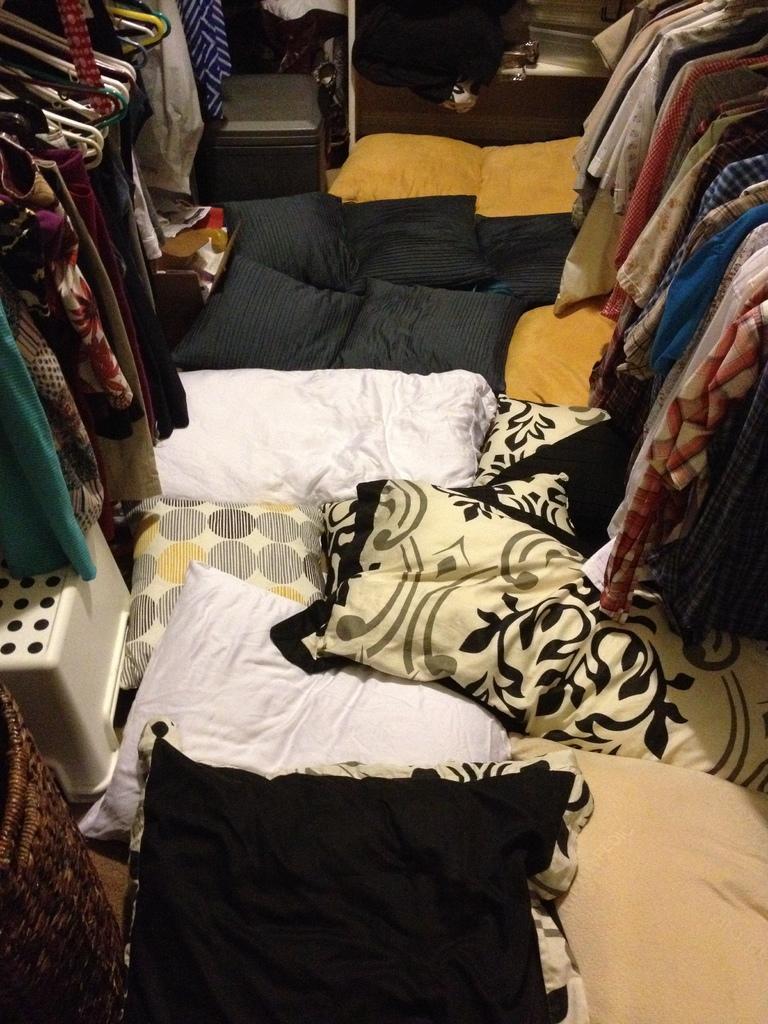In one or two sentences, can you explain what this image depicts? In this image in the center there are some pillows, and on the right side and left side there are clothes, hangers and there is a stool, basket. In the background there is a cupboard, in the cupboard there are objects. 